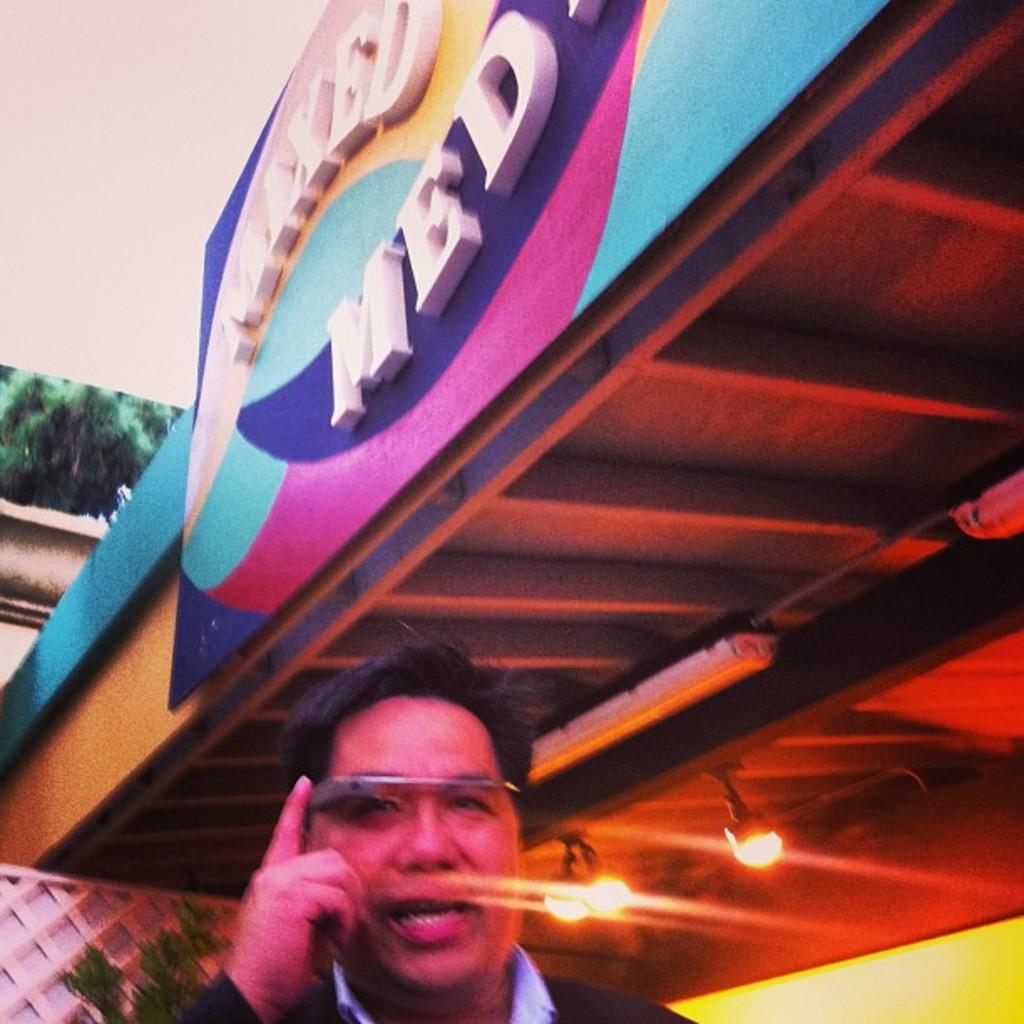What is the main structure in the image? There is a hoarding in the image. What is on top of the hoarding? There is a roof with lights on top of the hoarding. Who or what can be seen at the bottom of the image? A man is visible at the bottom of the image. What type of vegetation is in the background of the image? There is a plant in the background of the image. What can be used for cooking in the background of the image? There is a grill in the background of the image. What is the background of the image made of? There is a wall in the background of the image. What type of calculator is being used by the man in the image? There is no calculator visible in the image; a man is simply standing at the bottom. What type of camera is being used to take the picture of the scene? The question assumes that there is a camera taking the picture, which is not mentioned in the facts. The image itself is not a photograph, so the question is not applicable. 